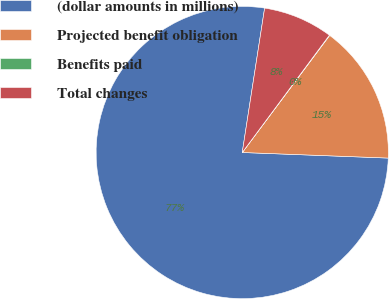<chart> <loc_0><loc_0><loc_500><loc_500><pie_chart><fcel>(dollar amounts in millions)<fcel>Projected benefit obligation<fcel>Benefits paid<fcel>Total changes<nl><fcel>76.84%<fcel>15.4%<fcel>0.04%<fcel>7.72%<nl></chart> 